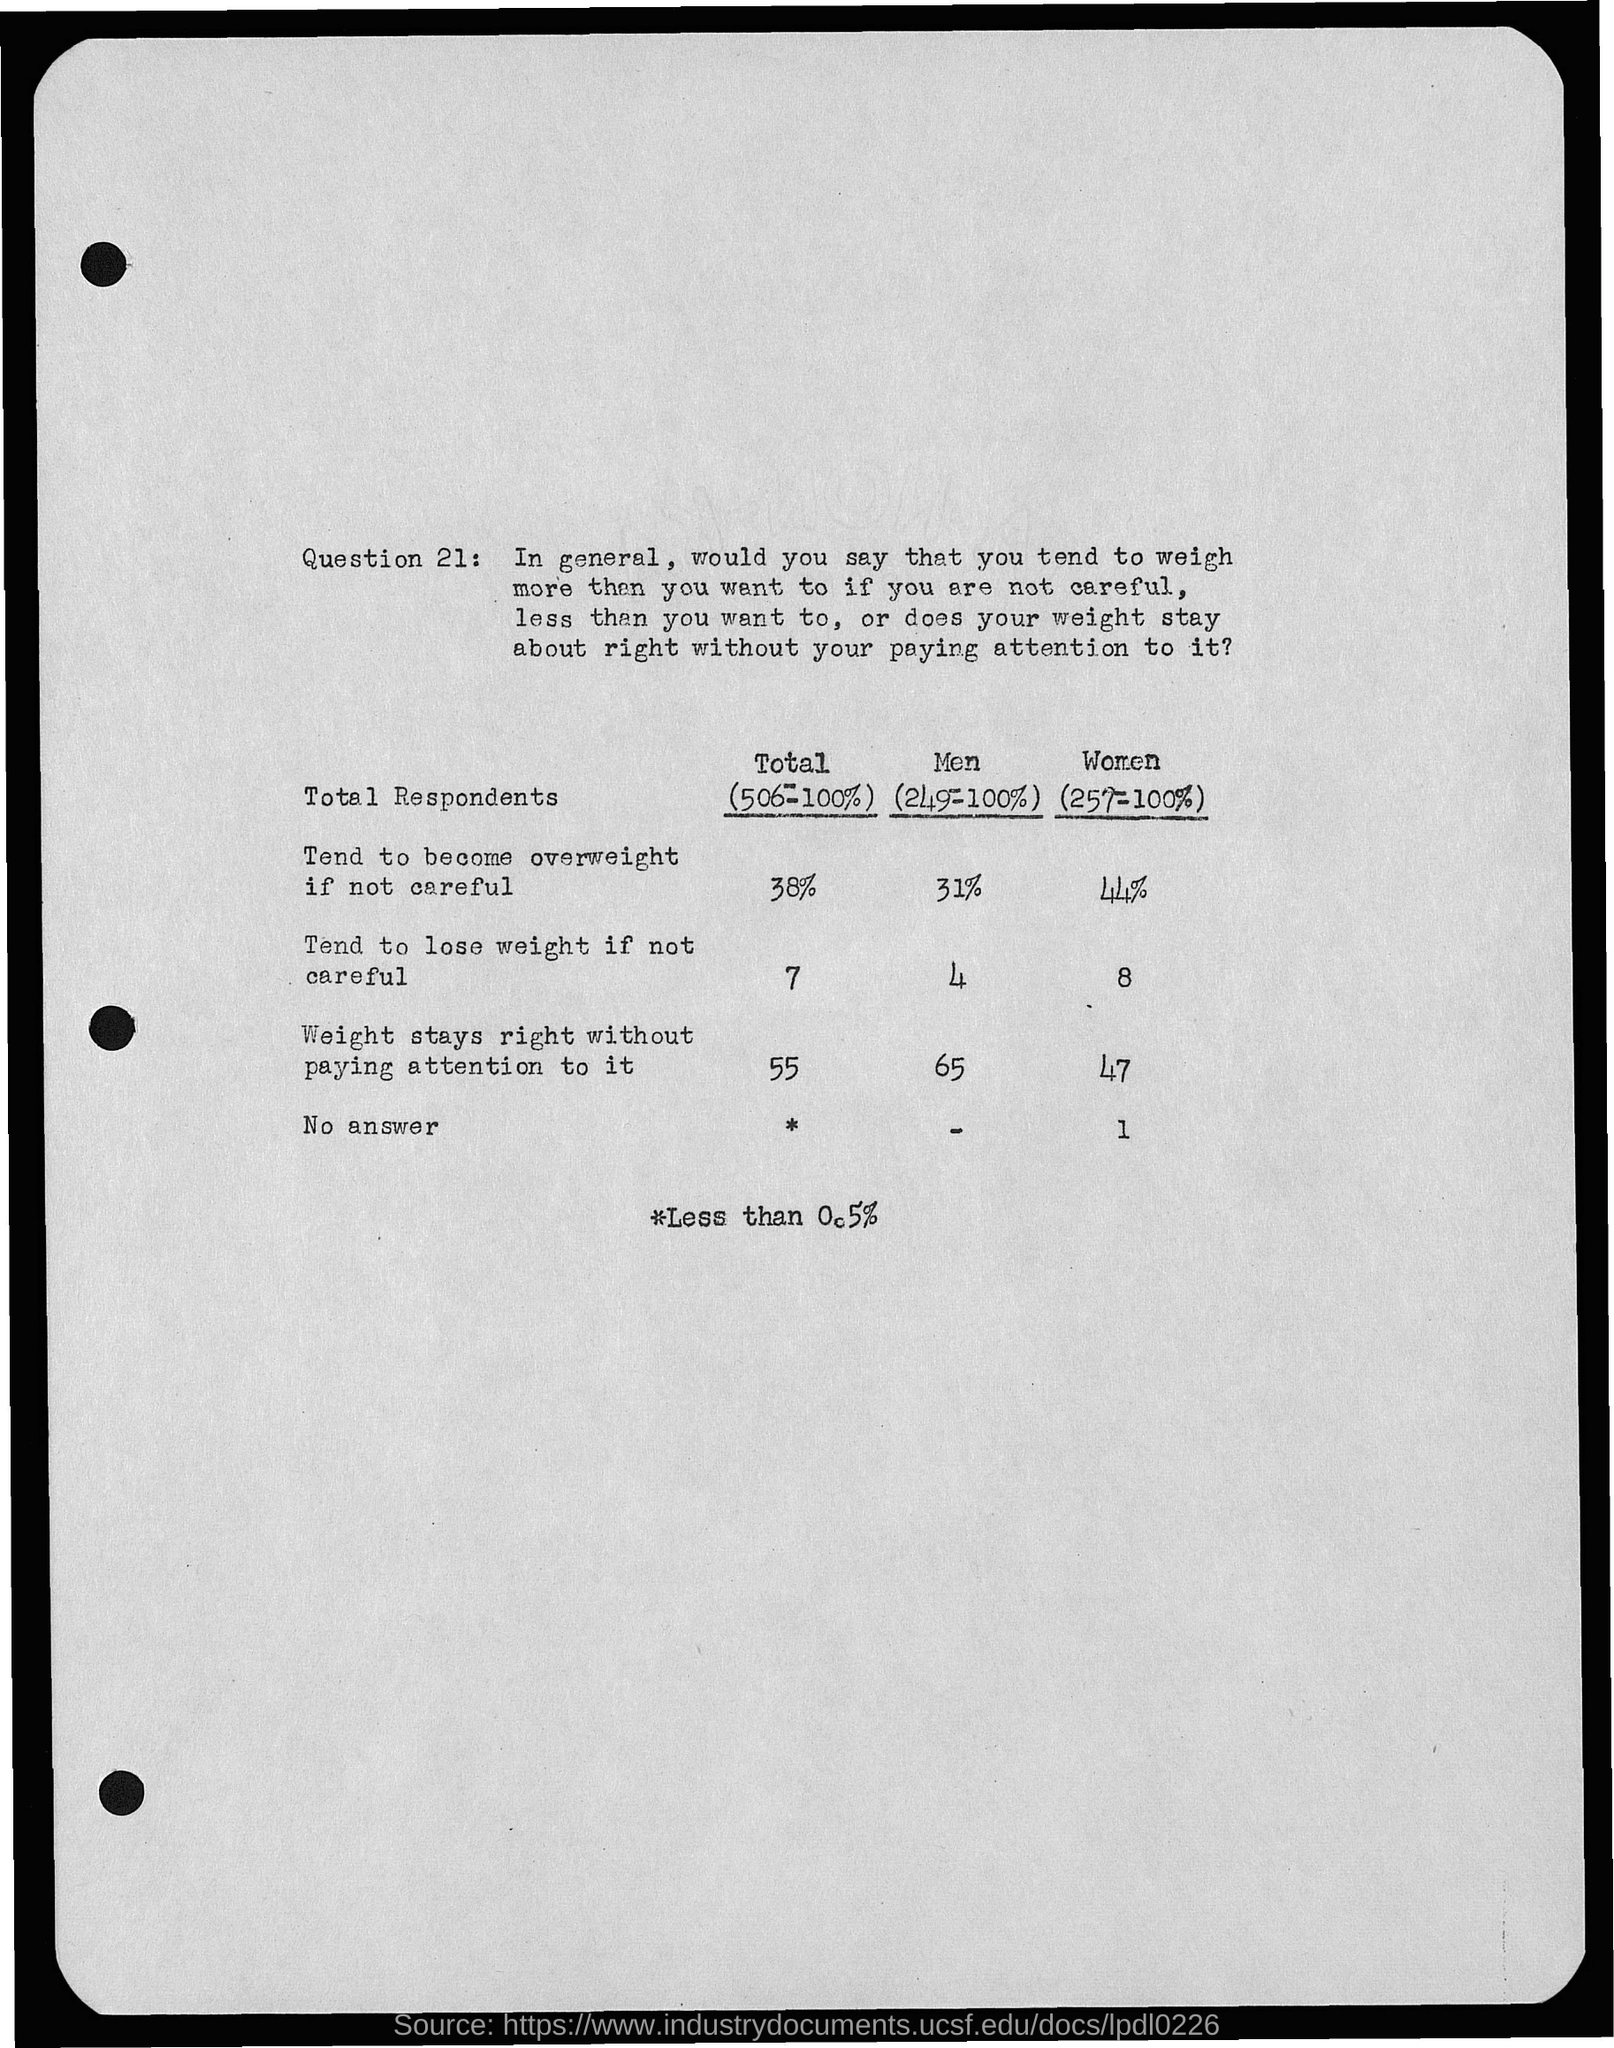What is the Total who tend to become overweight if not careful?
Offer a terse response. 38%. What is the Total who tend to lose weight if not careful?
Make the answer very short. 7. What is the Total whose weight stays right without paying attention to it?
Offer a terse response. 55. 